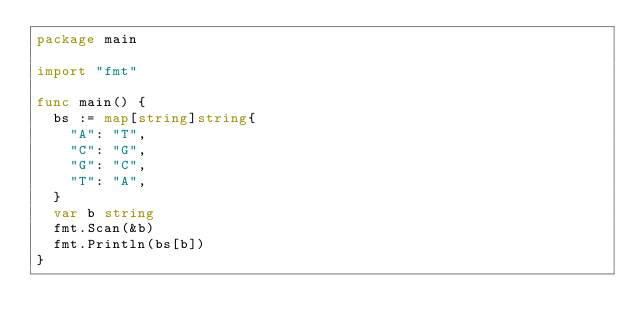Convert code to text. <code><loc_0><loc_0><loc_500><loc_500><_Go_>package main

import "fmt"

func main() {
  bs := map[string]string{
    "A": "T",
    "C": "G",
    "G": "C",
    "T": "A",
  }
  var b string
  fmt.Scan(&b)
  fmt.Println(bs[b])
}
</code> 